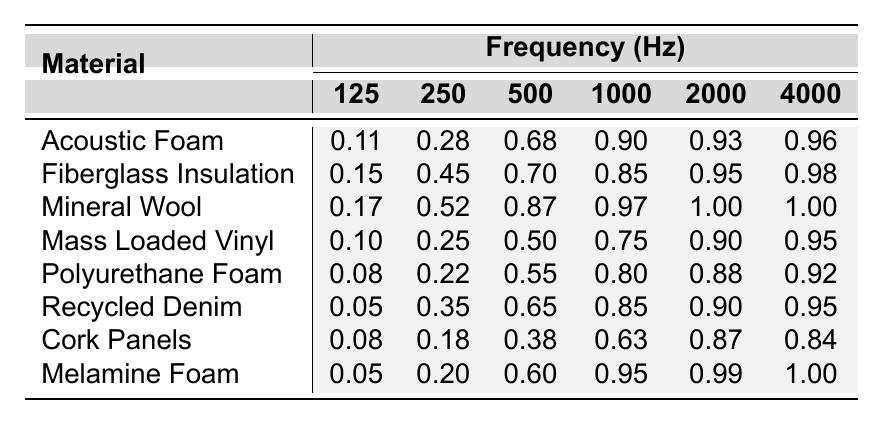What is the noise reduction coefficient of Acoustic Foam at 1000 Hz? According to the table, the noise reduction coefficient for Acoustic Foam at 1000 Hz is listed directly as 0.90.
Answer: 0.90 Which material has the highest noise reduction coefficient at 2000 Hz? By checking the values in the table, Mineral Wool has the highest coefficient at 2000 Hz, which is 1.00.
Answer: Mineral Wool What is the average noise reduction coefficient for Polyurethane Foam across all frequencies? To find the average, sum the coefficients (0.08 + 0.22 + 0.55 + 0.80 + 0.88 + 0.92 = 2.45) and divide by the number of frequencies (6). Therefore, the average is 2.45 / 6 = 0.4083.
Answer: 0.41 Does Melamine Foam provide a higher noise reduction coefficient at 125 Hz than Cork Panels? Looking at the table, Melamine Foam has a coefficient of 0.05 at 125 Hz, while Cork Panels have a coefficient of 0.08. Since 0.05 is less than 0.08, Melamine Foam does not provide a higher coefficient.
Answer: No What is the difference in noise reduction coefficients between Fiberglass Insulation and Mineral Wool at 500 Hz? Fiberglass Insulation has a coefficient of 0.70, while Mineral Wool has a coefficient of 0.87. The difference is calculated as 0.87 - 0.70 = 0.17.
Answer: 0.17 Which material has the most consistent noise reduction coefficients across all frequencies? By analyzing the table, Polyurethane Foam shows the least variation in its coefficients, ranging from 0.08 to 0.92. This indicates more consistency compared to others.
Answer: Polyurethane Foam Is there any material that achieves a noise reduction coefficient of 1.00 at any frequency? Yes, the table shows that both Mineral Wool and Melamine Foam achieve a coefficient of 1.00 at 4000 Hz.
Answer: Yes What frequency shows the highest noise reduction coefficient for Recycled Denim? Checking the table, Recycled Denim achieves the highest coefficient (0.95) at both 4000 Hz and 2000 Hz.
Answer: 4000 Hz Which material's noise reduction coefficient increases most significantly from 125 Hz to 4000 Hz? To find this, we can calculate the differences for each material: Acoustic Foam (0.85 increase), Fiberglass Insulation (0.83), Mineral Wool (0.83), Mass Loaded Vinyl (0.85), Polyurethane Foam (0.84), Recycled Denim (0.90), Cork Panels (0.76), Melamine Foam (0.95). The highest increase is seen in Melamine Foam (0.95).
Answer: Melamine Foam At 250 Hz, which two materials have very similar noise reduction coefficients? At 250 Hz, Fiberglass Insulation is at 0.45 and Recycled Denim is at 0.35. The coefficients are close but not very similar; instead, Cork Panels (0.18) substantially differs.
Answer: Fiberglass Insulation and Recycled Denim 